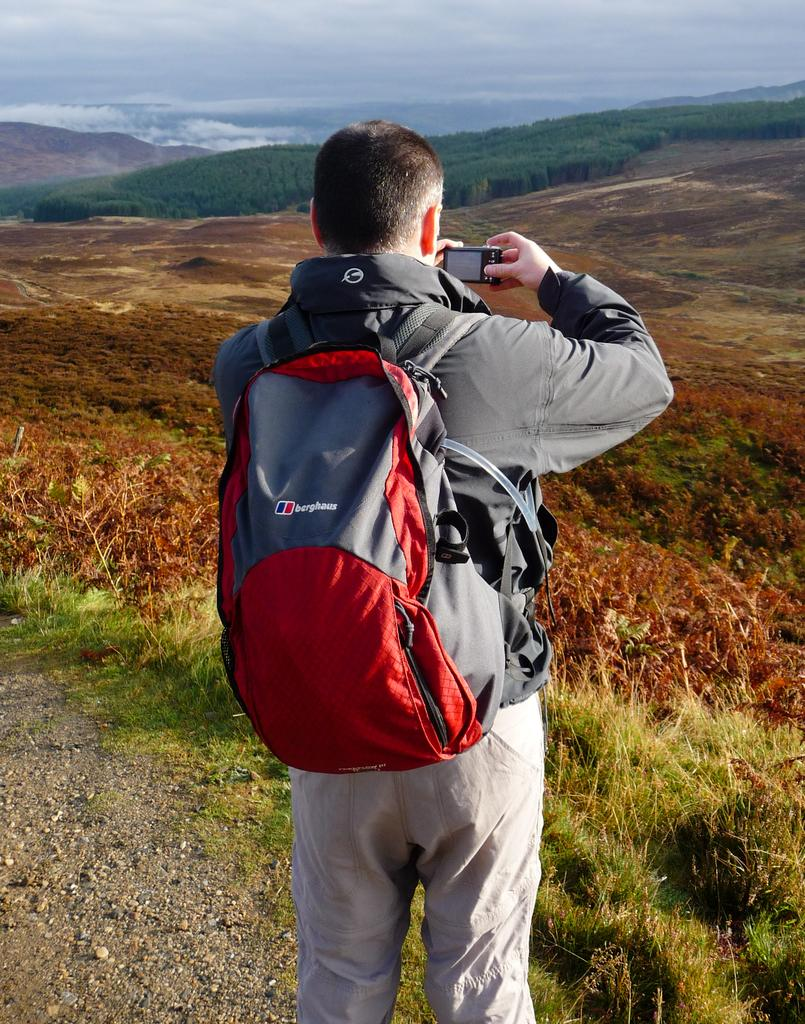What is the man in the image doing? The man is standing in the image and holding a wire bag and a camera. What might the man be planning to do with the items he is holding? The man might be planning to take pictures with the camera and store his belongings in the wire bag. What can be seen in the distance in the image? There are trees visible in the distance. What is the condition of the sky in the image? The sky is cloudy in the image. Can you see any fog in the image? No, there is no fog visible in the image. 